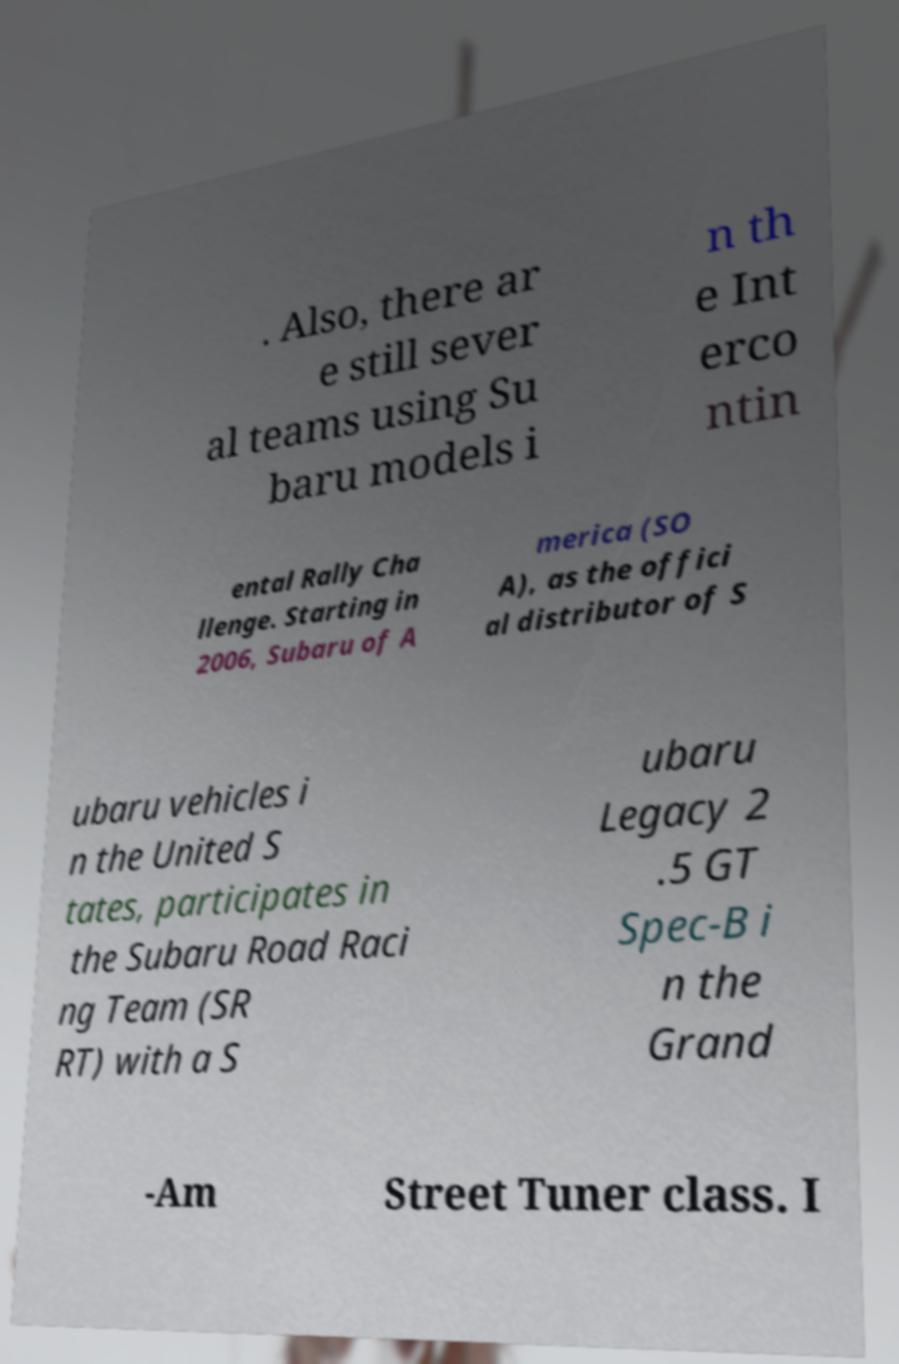For documentation purposes, I need the text within this image transcribed. Could you provide that? . Also, there ar e still sever al teams using Su baru models i n th e Int erco ntin ental Rally Cha llenge. Starting in 2006, Subaru of A merica (SO A), as the offici al distributor of S ubaru vehicles i n the United S tates, participates in the Subaru Road Raci ng Team (SR RT) with a S ubaru Legacy 2 .5 GT Spec-B i n the Grand -Am Street Tuner class. I 